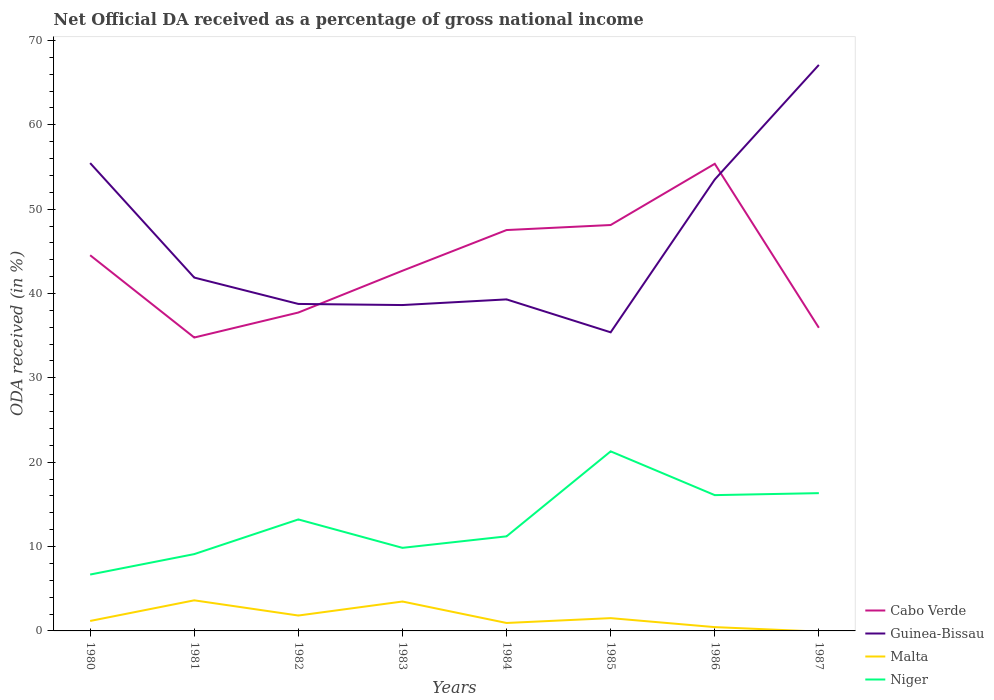Does the line corresponding to Malta intersect with the line corresponding to Guinea-Bissau?
Your answer should be compact. No. Across all years, what is the maximum net official DA received in Niger?
Offer a terse response. 6.68. What is the total net official DA received in Cabo Verde in the graph?
Provide a short and direct response. -10.84. What is the difference between the highest and the second highest net official DA received in Niger?
Provide a short and direct response. 14.6. What is the difference between the highest and the lowest net official DA received in Cabo Verde?
Ensure brevity in your answer.  4. Is the net official DA received in Guinea-Bissau strictly greater than the net official DA received in Malta over the years?
Ensure brevity in your answer.  No. How many lines are there?
Provide a short and direct response. 4. What is the difference between two consecutive major ticks on the Y-axis?
Your answer should be very brief. 10. Does the graph contain grids?
Provide a succinct answer. No. How many legend labels are there?
Your answer should be compact. 4. How are the legend labels stacked?
Ensure brevity in your answer.  Vertical. What is the title of the graph?
Ensure brevity in your answer.  Net Official DA received as a percentage of gross national income. Does "Haiti" appear as one of the legend labels in the graph?
Offer a terse response. No. What is the label or title of the Y-axis?
Make the answer very short. ODA received (in %). What is the ODA received (in %) in Cabo Verde in 1980?
Give a very brief answer. 44.54. What is the ODA received (in %) in Guinea-Bissau in 1980?
Your answer should be compact. 55.46. What is the ODA received (in %) in Malta in 1980?
Give a very brief answer. 1.18. What is the ODA received (in %) in Niger in 1980?
Keep it short and to the point. 6.68. What is the ODA received (in %) in Cabo Verde in 1981?
Offer a very short reply. 34.78. What is the ODA received (in %) in Guinea-Bissau in 1981?
Ensure brevity in your answer.  41.89. What is the ODA received (in %) in Malta in 1981?
Offer a terse response. 3.63. What is the ODA received (in %) in Niger in 1981?
Your answer should be compact. 9.11. What is the ODA received (in %) in Cabo Verde in 1982?
Give a very brief answer. 37.74. What is the ODA received (in %) in Guinea-Bissau in 1982?
Provide a succinct answer. 38.76. What is the ODA received (in %) of Malta in 1982?
Give a very brief answer. 1.83. What is the ODA received (in %) in Niger in 1982?
Offer a very short reply. 13.22. What is the ODA received (in %) of Cabo Verde in 1983?
Provide a succinct answer. 42.7. What is the ODA received (in %) in Guinea-Bissau in 1983?
Your answer should be very brief. 38.63. What is the ODA received (in %) in Malta in 1983?
Your response must be concise. 3.49. What is the ODA received (in %) of Niger in 1983?
Keep it short and to the point. 9.85. What is the ODA received (in %) of Cabo Verde in 1984?
Your answer should be compact. 47.52. What is the ODA received (in %) of Guinea-Bissau in 1984?
Provide a short and direct response. 39.3. What is the ODA received (in %) in Malta in 1984?
Your answer should be very brief. 0.94. What is the ODA received (in %) in Niger in 1984?
Ensure brevity in your answer.  11.21. What is the ODA received (in %) of Cabo Verde in 1985?
Your response must be concise. 48.12. What is the ODA received (in %) in Guinea-Bissau in 1985?
Ensure brevity in your answer.  35.4. What is the ODA received (in %) of Malta in 1985?
Ensure brevity in your answer.  1.52. What is the ODA received (in %) of Niger in 1985?
Your answer should be compact. 21.29. What is the ODA received (in %) of Cabo Verde in 1986?
Offer a terse response. 55.37. What is the ODA received (in %) in Guinea-Bissau in 1986?
Your response must be concise. 53.51. What is the ODA received (in %) in Malta in 1986?
Offer a very short reply. 0.45. What is the ODA received (in %) of Niger in 1986?
Make the answer very short. 16.1. What is the ODA received (in %) of Cabo Verde in 1987?
Offer a terse response. 35.94. What is the ODA received (in %) in Guinea-Bissau in 1987?
Provide a short and direct response. 67.1. What is the ODA received (in %) in Niger in 1987?
Your response must be concise. 16.33. Across all years, what is the maximum ODA received (in %) in Cabo Verde?
Provide a succinct answer. 55.37. Across all years, what is the maximum ODA received (in %) in Guinea-Bissau?
Your response must be concise. 67.1. Across all years, what is the maximum ODA received (in %) in Malta?
Offer a very short reply. 3.63. Across all years, what is the maximum ODA received (in %) of Niger?
Give a very brief answer. 21.29. Across all years, what is the minimum ODA received (in %) of Cabo Verde?
Your answer should be very brief. 34.78. Across all years, what is the minimum ODA received (in %) of Guinea-Bissau?
Provide a succinct answer. 35.4. Across all years, what is the minimum ODA received (in %) of Niger?
Make the answer very short. 6.68. What is the total ODA received (in %) of Cabo Verde in the graph?
Your response must be concise. 346.7. What is the total ODA received (in %) in Guinea-Bissau in the graph?
Your response must be concise. 370.05. What is the total ODA received (in %) in Malta in the graph?
Provide a succinct answer. 13.03. What is the total ODA received (in %) in Niger in the graph?
Offer a terse response. 103.78. What is the difference between the ODA received (in %) of Cabo Verde in 1980 and that in 1981?
Offer a very short reply. 9.75. What is the difference between the ODA received (in %) in Guinea-Bissau in 1980 and that in 1981?
Provide a succinct answer. 13.57. What is the difference between the ODA received (in %) in Malta in 1980 and that in 1981?
Make the answer very short. -2.44. What is the difference between the ODA received (in %) in Niger in 1980 and that in 1981?
Provide a succinct answer. -2.42. What is the difference between the ODA received (in %) in Cabo Verde in 1980 and that in 1982?
Your response must be concise. 6.79. What is the difference between the ODA received (in %) in Guinea-Bissau in 1980 and that in 1982?
Give a very brief answer. 16.7. What is the difference between the ODA received (in %) of Malta in 1980 and that in 1982?
Offer a terse response. -0.64. What is the difference between the ODA received (in %) of Niger in 1980 and that in 1982?
Ensure brevity in your answer.  -6.53. What is the difference between the ODA received (in %) of Cabo Verde in 1980 and that in 1983?
Your response must be concise. 1.84. What is the difference between the ODA received (in %) of Guinea-Bissau in 1980 and that in 1983?
Give a very brief answer. 16.83. What is the difference between the ODA received (in %) in Malta in 1980 and that in 1983?
Give a very brief answer. -2.3. What is the difference between the ODA received (in %) in Niger in 1980 and that in 1983?
Provide a short and direct response. -3.17. What is the difference between the ODA received (in %) in Cabo Verde in 1980 and that in 1984?
Your answer should be very brief. -2.99. What is the difference between the ODA received (in %) in Guinea-Bissau in 1980 and that in 1984?
Keep it short and to the point. 16.16. What is the difference between the ODA received (in %) of Malta in 1980 and that in 1984?
Your response must be concise. 0.24. What is the difference between the ODA received (in %) in Niger in 1980 and that in 1984?
Provide a succinct answer. -4.53. What is the difference between the ODA received (in %) of Cabo Verde in 1980 and that in 1985?
Give a very brief answer. -3.58. What is the difference between the ODA received (in %) of Guinea-Bissau in 1980 and that in 1985?
Provide a succinct answer. 20.06. What is the difference between the ODA received (in %) of Malta in 1980 and that in 1985?
Your answer should be compact. -0.33. What is the difference between the ODA received (in %) in Niger in 1980 and that in 1985?
Offer a terse response. -14.6. What is the difference between the ODA received (in %) of Cabo Verde in 1980 and that in 1986?
Your answer should be compact. -10.84. What is the difference between the ODA received (in %) of Guinea-Bissau in 1980 and that in 1986?
Provide a short and direct response. 1.95. What is the difference between the ODA received (in %) of Malta in 1980 and that in 1986?
Offer a very short reply. 0.73. What is the difference between the ODA received (in %) in Niger in 1980 and that in 1986?
Keep it short and to the point. -9.42. What is the difference between the ODA received (in %) of Cabo Verde in 1980 and that in 1987?
Make the answer very short. 8.6. What is the difference between the ODA received (in %) of Guinea-Bissau in 1980 and that in 1987?
Provide a succinct answer. -11.64. What is the difference between the ODA received (in %) of Niger in 1980 and that in 1987?
Keep it short and to the point. -9.65. What is the difference between the ODA received (in %) in Cabo Verde in 1981 and that in 1982?
Your answer should be very brief. -2.96. What is the difference between the ODA received (in %) of Guinea-Bissau in 1981 and that in 1982?
Offer a very short reply. 3.12. What is the difference between the ODA received (in %) of Malta in 1981 and that in 1982?
Give a very brief answer. 1.8. What is the difference between the ODA received (in %) in Niger in 1981 and that in 1982?
Your answer should be compact. -4.11. What is the difference between the ODA received (in %) of Cabo Verde in 1981 and that in 1983?
Your answer should be very brief. -7.92. What is the difference between the ODA received (in %) in Guinea-Bissau in 1981 and that in 1983?
Your answer should be compact. 3.26. What is the difference between the ODA received (in %) in Malta in 1981 and that in 1983?
Offer a terse response. 0.14. What is the difference between the ODA received (in %) in Niger in 1981 and that in 1983?
Keep it short and to the point. -0.74. What is the difference between the ODA received (in %) in Cabo Verde in 1981 and that in 1984?
Your answer should be very brief. -12.74. What is the difference between the ODA received (in %) of Guinea-Bissau in 1981 and that in 1984?
Your response must be concise. 2.59. What is the difference between the ODA received (in %) in Malta in 1981 and that in 1984?
Keep it short and to the point. 2.68. What is the difference between the ODA received (in %) in Niger in 1981 and that in 1984?
Provide a succinct answer. -2.11. What is the difference between the ODA received (in %) in Cabo Verde in 1981 and that in 1985?
Provide a short and direct response. -13.34. What is the difference between the ODA received (in %) of Guinea-Bissau in 1981 and that in 1985?
Your answer should be very brief. 6.49. What is the difference between the ODA received (in %) in Malta in 1981 and that in 1985?
Provide a short and direct response. 2.11. What is the difference between the ODA received (in %) in Niger in 1981 and that in 1985?
Your answer should be very brief. -12.18. What is the difference between the ODA received (in %) of Cabo Verde in 1981 and that in 1986?
Make the answer very short. -20.59. What is the difference between the ODA received (in %) of Guinea-Bissau in 1981 and that in 1986?
Your response must be concise. -11.63. What is the difference between the ODA received (in %) of Malta in 1981 and that in 1986?
Offer a terse response. 3.18. What is the difference between the ODA received (in %) in Niger in 1981 and that in 1986?
Make the answer very short. -6.99. What is the difference between the ODA received (in %) in Cabo Verde in 1981 and that in 1987?
Offer a terse response. -1.16. What is the difference between the ODA received (in %) in Guinea-Bissau in 1981 and that in 1987?
Your answer should be very brief. -25.21. What is the difference between the ODA received (in %) in Niger in 1981 and that in 1987?
Your response must be concise. -7.23. What is the difference between the ODA received (in %) in Cabo Verde in 1982 and that in 1983?
Provide a succinct answer. -4.95. What is the difference between the ODA received (in %) of Guinea-Bissau in 1982 and that in 1983?
Provide a succinct answer. 0.13. What is the difference between the ODA received (in %) in Malta in 1982 and that in 1983?
Your response must be concise. -1.66. What is the difference between the ODA received (in %) of Niger in 1982 and that in 1983?
Make the answer very short. 3.37. What is the difference between the ODA received (in %) of Cabo Verde in 1982 and that in 1984?
Your answer should be compact. -9.78. What is the difference between the ODA received (in %) of Guinea-Bissau in 1982 and that in 1984?
Provide a short and direct response. -0.54. What is the difference between the ODA received (in %) in Malta in 1982 and that in 1984?
Provide a succinct answer. 0.88. What is the difference between the ODA received (in %) in Niger in 1982 and that in 1984?
Make the answer very short. 2. What is the difference between the ODA received (in %) in Cabo Verde in 1982 and that in 1985?
Provide a short and direct response. -10.37. What is the difference between the ODA received (in %) of Guinea-Bissau in 1982 and that in 1985?
Provide a short and direct response. 3.36. What is the difference between the ODA received (in %) of Malta in 1982 and that in 1985?
Provide a short and direct response. 0.31. What is the difference between the ODA received (in %) of Niger in 1982 and that in 1985?
Your answer should be compact. -8.07. What is the difference between the ODA received (in %) in Cabo Verde in 1982 and that in 1986?
Offer a very short reply. -17.63. What is the difference between the ODA received (in %) in Guinea-Bissau in 1982 and that in 1986?
Ensure brevity in your answer.  -14.75. What is the difference between the ODA received (in %) of Malta in 1982 and that in 1986?
Provide a short and direct response. 1.37. What is the difference between the ODA received (in %) in Niger in 1982 and that in 1986?
Ensure brevity in your answer.  -2.88. What is the difference between the ODA received (in %) of Cabo Verde in 1982 and that in 1987?
Offer a very short reply. 1.81. What is the difference between the ODA received (in %) of Guinea-Bissau in 1982 and that in 1987?
Keep it short and to the point. -28.33. What is the difference between the ODA received (in %) in Niger in 1982 and that in 1987?
Ensure brevity in your answer.  -3.12. What is the difference between the ODA received (in %) of Cabo Verde in 1983 and that in 1984?
Make the answer very short. -4.82. What is the difference between the ODA received (in %) in Guinea-Bissau in 1983 and that in 1984?
Your response must be concise. -0.67. What is the difference between the ODA received (in %) of Malta in 1983 and that in 1984?
Give a very brief answer. 2.54. What is the difference between the ODA received (in %) of Niger in 1983 and that in 1984?
Offer a terse response. -1.36. What is the difference between the ODA received (in %) in Cabo Verde in 1983 and that in 1985?
Keep it short and to the point. -5.42. What is the difference between the ODA received (in %) in Guinea-Bissau in 1983 and that in 1985?
Keep it short and to the point. 3.23. What is the difference between the ODA received (in %) of Malta in 1983 and that in 1985?
Provide a succinct answer. 1.97. What is the difference between the ODA received (in %) in Niger in 1983 and that in 1985?
Your response must be concise. -11.44. What is the difference between the ODA received (in %) in Cabo Verde in 1983 and that in 1986?
Ensure brevity in your answer.  -12.68. What is the difference between the ODA received (in %) in Guinea-Bissau in 1983 and that in 1986?
Provide a succinct answer. -14.88. What is the difference between the ODA received (in %) of Malta in 1983 and that in 1986?
Ensure brevity in your answer.  3.03. What is the difference between the ODA received (in %) of Niger in 1983 and that in 1986?
Ensure brevity in your answer.  -6.25. What is the difference between the ODA received (in %) in Cabo Verde in 1983 and that in 1987?
Ensure brevity in your answer.  6.76. What is the difference between the ODA received (in %) of Guinea-Bissau in 1983 and that in 1987?
Your answer should be very brief. -28.47. What is the difference between the ODA received (in %) in Niger in 1983 and that in 1987?
Provide a succinct answer. -6.48. What is the difference between the ODA received (in %) of Cabo Verde in 1984 and that in 1985?
Ensure brevity in your answer.  -0.6. What is the difference between the ODA received (in %) in Guinea-Bissau in 1984 and that in 1985?
Make the answer very short. 3.9. What is the difference between the ODA received (in %) of Malta in 1984 and that in 1985?
Provide a short and direct response. -0.57. What is the difference between the ODA received (in %) in Niger in 1984 and that in 1985?
Your answer should be compact. -10.07. What is the difference between the ODA received (in %) in Cabo Verde in 1984 and that in 1986?
Give a very brief answer. -7.85. What is the difference between the ODA received (in %) of Guinea-Bissau in 1984 and that in 1986?
Provide a short and direct response. -14.21. What is the difference between the ODA received (in %) in Malta in 1984 and that in 1986?
Offer a very short reply. 0.49. What is the difference between the ODA received (in %) of Niger in 1984 and that in 1986?
Your response must be concise. -4.89. What is the difference between the ODA received (in %) in Cabo Verde in 1984 and that in 1987?
Your answer should be very brief. 11.59. What is the difference between the ODA received (in %) in Guinea-Bissau in 1984 and that in 1987?
Keep it short and to the point. -27.8. What is the difference between the ODA received (in %) of Niger in 1984 and that in 1987?
Give a very brief answer. -5.12. What is the difference between the ODA received (in %) of Cabo Verde in 1985 and that in 1986?
Your answer should be very brief. -7.26. What is the difference between the ODA received (in %) of Guinea-Bissau in 1985 and that in 1986?
Keep it short and to the point. -18.12. What is the difference between the ODA received (in %) of Malta in 1985 and that in 1986?
Offer a very short reply. 1.06. What is the difference between the ODA received (in %) in Niger in 1985 and that in 1986?
Give a very brief answer. 5.19. What is the difference between the ODA received (in %) of Cabo Verde in 1985 and that in 1987?
Provide a short and direct response. 12.18. What is the difference between the ODA received (in %) of Guinea-Bissau in 1985 and that in 1987?
Keep it short and to the point. -31.7. What is the difference between the ODA received (in %) in Niger in 1985 and that in 1987?
Provide a succinct answer. 4.95. What is the difference between the ODA received (in %) of Cabo Verde in 1986 and that in 1987?
Your response must be concise. 19.44. What is the difference between the ODA received (in %) of Guinea-Bissau in 1986 and that in 1987?
Offer a very short reply. -13.58. What is the difference between the ODA received (in %) of Niger in 1986 and that in 1987?
Keep it short and to the point. -0.23. What is the difference between the ODA received (in %) of Cabo Verde in 1980 and the ODA received (in %) of Guinea-Bissau in 1981?
Give a very brief answer. 2.65. What is the difference between the ODA received (in %) in Cabo Verde in 1980 and the ODA received (in %) in Malta in 1981?
Give a very brief answer. 40.91. What is the difference between the ODA received (in %) of Cabo Verde in 1980 and the ODA received (in %) of Niger in 1981?
Offer a terse response. 35.43. What is the difference between the ODA received (in %) in Guinea-Bissau in 1980 and the ODA received (in %) in Malta in 1981?
Your answer should be compact. 51.83. What is the difference between the ODA received (in %) of Guinea-Bissau in 1980 and the ODA received (in %) of Niger in 1981?
Provide a short and direct response. 46.35. What is the difference between the ODA received (in %) of Malta in 1980 and the ODA received (in %) of Niger in 1981?
Your response must be concise. -7.92. What is the difference between the ODA received (in %) in Cabo Verde in 1980 and the ODA received (in %) in Guinea-Bissau in 1982?
Your answer should be very brief. 5.77. What is the difference between the ODA received (in %) in Cabo Verde in 1980 and the ODA received (in %) in Malta in 1982?
Give a very brief answer. 42.71. What is the difference between the ODA received (in %) of Cabo Verde in 1980 and the ODA received (in %) of Niger in 1982?
Keep it short and to the point. 31.32. What is the difference between the ODA received (in %) of Guinea-Bissau in 1980 and the ODA received (in %) of Malta in 1982?
Offer a very short reply. 53.63. What is the difference between the ODA received (in %) in Guinea-Bissau in 1980 and the ODA received (in %) in Niger in 1982?
Provide a short and direct response. 42.24. What is the difference between the ODA received (in %) in Malta in 1980 and the ODA received (in %) in Niger in 1982?
Your response must be concise. -12.03. What is the difference between the ODA received (in %) in Cabo Verde in 1980 and the ODA received (in %) in Guinea-Bissau in 1983?
Ensure brevity in your answer.  5.9. What is the difference between the ODA received (in %) in Cabo Verde in 1980 and the ODA received (in %) in Malta in 1983?
Your answer should be very brief. 41.05. What is the difference between the ODA received (in %) of Cabo Verde in 1980 and the ODA received (in %) of Niger in 1983?
Your response must be concise. 34.69. What is the difference between the ODA received (in %) of Guinea-Bissau in 1980 and the ODA received (in %) of Malta in 1983?
Keep it short and to the point. 51.97. What is the difference between the ODA received (in %) in Guinea-Bissau in 1980 and the ODA received (in %) in Niger in 1983?
Provide a succinct answer. 45.61. What is the difference between the ODA received (in %) of Malta in 1980 and the ODA received (in %) of Niger in 1983?
Provide a succinct answer. -8.67. What is the difference between the ODA received (in %) of Cabo Verde in 1980 and the ODA received (in %) of Guinea-Bissau in 1984?
Provide a succinct answer. 5.23. What is the difference between the ODA received (in %) of Cabo Verde in 1980 and the ODA received (in %) of Malta in 1984?
Ensure brevity in your answer.  43.59. What is the difference between the ODA received (in %) in Cabo Verde in 1980 and the ODA received (in %) in Niger in 1984?
Offer a very short reply. 33.32. What is the difference between the ODA received (in %) in Guinea-Bissau in 1980 and the ODA received (in %) in Malta in 1984?
Give a very brief answer. 54.52. What is the difference between the ODA received (in %) in Guinea-Bissau in 1980 and the ODA received (in %) in Niger in 1984?
Your answer should be compact. 44.25. What is the difference between the ODA received (in %) in Malta in 1980 and the ODA received (in %) in Niger in 1984?
Provide a short and direct response. -10.03. What is the difference between the ODA received (in %) in Cabo Verde in 1980 and the ODA received (in %) in Guinea-Bissau in 1985?
Your response must be concise. 9.14. What is the difference between the ODA received (in %) in Cabo Verde in 1980 and the ODA received (in %) in Malta in 1985?
Ensure brevity in your answer.  43.02. What is the difference between the ODA received (in %) in Cabo Verde in 1980 and the ODA received (in %) in Niger in 1985?
Offer a very short reply. 23.25. What is the difference between the ODA received (in %) of Guinea-Bissau in 1980 and the ODA received (in %) of Malta in 1985?
Give a very brief answer. 53.94. What is the difference between the ODA received (in %) in Guinea-Bissau in 1980 and the ODA received (in %) in Niger in 1985?
Your answer should be very brief. 34.17. What is the difference between the ODA received (in %) in Malta in 1980 and the ODA received (in %) in Niger in 1985?
Keep it short and to the point. -20.1. What is the difference between the ODA received (in %) in Cabo Verde in 1980 and the ODA received (in %) in Guinea-Bissau in 1986?
Ensure brevity in your answer.  -8.98. What is the difference between the ODA received (in %) of Cabo Verde in 1980 and the ODA received (in %) of Malta in 1986?
Ensure brevity in your answer.  44.08. What is the difference between the ODA received (in %) in Cabo Verde in 1980 and the ODA received (in %) in Niger in 1986?
Your response must be concise. 28.44. What is the difference between the ODA received (in %) of Guinea-Bissau in 1980 and the ODA received (in %) of Malta in 1986?
Keep it short and to the point. 55.01. What is the difference between the ODA received (in %) in Guinea-Bissau in 1980 and the ODA received (in %) in Niger in 1986?
Your answer should be very brief. 39.36. What is the difference between the ODA received (in %) in Malta in 1980 and the ODA received (in %) in Niger in 1986?
Make the answer very short. -14.92. What is the difference between the ODA received (in %) in Cabo Verde in 1980 and the ODA received (in %) in Guinea-Bissau in 1987?
Your response must be concise. -22.56. What is the difference between the ODA received (in %) of Cabo Verde in 1980 and the ODA received (in %) of Niger in 1987?
Provide a succinct answer. 28.2. What is the difference between the ODA received (in %) of Guinea-Bissau in 1980 and the ODA received (in %) of Niger in 1987?
Your answer should be very brief. 39.13. What is the difference between the ODA received (in %) in Malta in 1980 and the ODA received (in %) in Niger in 1987?
Your answer should be compact. -15.15. What is the difference between the ODA received (in %) of Cabo Verde in 1981 and the ODA received (in %) of Guinea-Bissau in 1982?
Ensure brevity in your answer.  -3.98. What is the difference between the ODA received (in %) in Cabo Verde in 1981 and the ODA received (in %) in Malta in 1982?
Ensure brevity in your answer.  32.95. What is the difference between the ODA received (in %) in Cabo Verde in 1981 and the ODA received (in %) in Niger in 1982?
Your answer should be compact. 21.57. What is the difference between the ODA received (in %) of Guinea-Bissau in 1981 and the ODA received (in %) of Malta in 1982?
Your response must be concise. 40.06. What is the difference between the ODA received (in %) in Guinea-Bissau in 1981 and the ODA received (in %) in Niger in 1982?
Offer a terse response. 28.67. What is the difference between the ODA received (in %) of Malta in 1981 and the ODA received (in %) of Niger in 1982?
Your answer should be very brief. -9.59. What is the difference between the ODA received (in %) of Cabo Verde in 1981 and the ODA received (in %) of Guinea-Bissau in 1983?
Provide a succinct answer. -3.85. What is the difference between the ODA received (in %) of Cabo Verde in 1981 and the ODA received (in %) of Malta in 1983?
Provide a succinct answer. 31.29. What is the difference between the ODA received (in %) of Cabo Verde in 1981 and the ODA received (in %) of Niger in 1983?
Your answer should be very brief. 24.93. What is the difference between the ODA received (in %) of Guinea-Bissau in 1981 and the ODA received (in %) of Malta in 1983?
Provide a succinct answer. 38.4. What is the difference between the ODA received (in %) of Guinea-Bissau in 1981 and the ODA received (in %) of Niger in 1983?
Ensure brevity in your answer.  32.04. What is the difference between the ODA received (in %) in Malta in 1981 and the ODA received (in %) in Niger in 1983?
Make the answer very short. -6.22. What is the difference between the ODA received (in %) of Cabo Verde in 1981 and the ODA received (in %) of Guinea-Bissau in 1984?
Your answer should be very brief. -4.52. What is the difference between the ODA received (in %) in Cabo Verde in 1981 and the ODA received (in %) in Malta in 1984?
Your answer should be compact. 33.84. What is the difference between the ODA received (in %) in Cabo Verde in 1981 and the ODA received (in %) in Niger in 1984?
Offer a terse response. 23.57. What is the difference between the ODA received (in %) of Guinea-Bissau in 1981 and the ODA received (in %) of Malta in 1984?
Your answer should be very brief. 40.94. What is the difference between the ODA received (in %) of Guinea-Bissau in 1981 and the ODA received (in %) of Niger in 1984?
Your response must be concise. 30.67. What is the difference between the ODA received (in %) in Malta in 1981 and the ODA received (in %) in Niger in 1984?
Keep it short and to the point. -7.59. What is the difference between the ODA received (in %) in Cabo Verde in 1981 and the ODA received (in %) in Guinea-Bissau in 1985?
Make the answer very short. -0.62. What is the difference between the ODA received (in %) in Cabo Verde in 1981 and the ODA received (in %) in Malta in 1985?
Provide a short and direct response. 33.26. What is the difference between the ODA received (in %) in Cabo Verde in 1981 and the ODA received (in %) in Niger in 1985?
Your response must be concise. 13.49. What is the difference between the ODA received (in %) of Guinea-Bissau in 1981 and the ODA received (in %) of Malta in 1985?
Offer a terse response. 40.37. What is the difference between the ODA received (in %) in Guinea-Bissau in 1981 and the ODA received (in %) in Niger in 1985?
Provide a short and direct response. 20.6. What is the difference between the ODA received (in %) in Malta in 1981 and the ODA received (in %) in Niger in 1985?
Keep it short and to the point. -17.66. What is the difference between the ODA received (in %) in Cabo Verde in 1981 and the ODA received (in %) in Guinea-Bissau in 1986?
Your response must be concise. -18.73. What is the difference between the ODA received (in %) in Cabo Verde in 1981 and the ODA received (in %) in Malta in 1986?
Offer a very short reply. 34.33. What is the difference between the ODA received (in %) in Cabo Verde in 1981 and the ODA received (in %) in Niger in 1986?
Keep it short and to the point. 18.68. What is the difference between the ODA received (in %) of Guinea-Bissau in 1981 and the ODA received (in %) of Malta in 1986?
Make the answer very short. 41.44. What is the difference between the ODA received (in %) of Guinea-Bissau in 1981 and the ODA received (in %) of Niger in 1986?
Give a very brief answer. 25.79. What is the difference between the ODA received (in %) in Malta in 1981 and the ODA received (in %) in Niger in 1986?
Your answer should be very brief. -12.47. What is the difference between the ODA received (in %) in Cabo Verde in 1981 and the ODA received (in %) in Guinea-Bissau in 1987?
Offer a very short reply. -32.32. What is the difference between the ODA received (in %) of Cabo Verde in 1981 and the ODA received (in %) of Niger in 1987?
Your answer should be very brief. 18.45. What is the difference between the ODA received (in %) of Guinea-Bissau in 1981 and the ODA received (in %) of Niger in 1987?
Provide a short and direct response. 25.55. What is the difference between the ODA received (in %) in Malta in 1981 and the ODA received (in %) in Niger in 1987?
Provide a succinct answer. -12.71. What is the difference between the ODA received (in %) of Cabo Verde in 1982 and the ODA received (in %) of Guinea-Bissau in 1983?
Offer a terse response. -0.89. What is the difference between the ODA received (in %) in Cabo Verde in 1982 and the ODA received (in %) in Malta in 1983?
Provide a succinct answer. 34.26. What is the difference between the ODA received (in %) in Cabo Verde in 1982 and the ODA received (in %) in Niger in 1983?
Your answer should be compact. 27.89. What is the difference between the ODA received (in %) of Guinea-Bissau in 1982 and the ODA received (in %) of Malta in 1983?
Make the answer very short. 35.28. What is the difference between the ODA received (in %) of Guinea-Bissau in 1982 and the ODA received (in %) of Niger in 1983?
Offer a terse response. 28.91. What is the difference between the ODA received (in %) of Malta in 1982 and the ODA received (in %) of Niger in 1983?
Make the answer very short. -8.02. What is the difference between the ODA received (in %) in Cabo Verde in 1982 and the ODA received (in %) in Guinea-Bissau in 1984?
Give a very brief answer. -1.56. What is the difference between the ODA received (in %) of Cabo Verde in 1982 and the ODA received (in %) of Malta in 1984?
Your answer should be very brief. 36.8. What is the difference between the ODA received (in %) in Cabo Verde in 1982 and the ODA received (in %) in Niger in 1984?
Provide a short and direct response. 26.53. What is the difference between the ODA received (in %) in Guinea-Bissau in 1982 and the ODA received (in %) in Malta in 1984?
Your response must be concise. 37.82. What is the difference between the ODA received (in %) in Guinea-Bissau in 1982 and the ODA received (in %) in Niger in 1984?
Keep it short and to the point. 27.55. What is the difference between the ODA received (in %) in Malta in 1982 and the ODA received (in %) in Niger in 1984?
Keep it short and to the point. -9.39. What is the difference between the ODA received (in %) of Cabo Verde in 1982 and the ODA received (in %) of Guinea-Bissau in 1985?
Make the answer very short. 2.35. What is the difference between the ODA received (in %) in Cabo Verde in 1982 and the ODA received (in %) in Malta in 1985?
Make the answer very short. 36.23. What is the difference between the ODA received (in %) in Cabo Verde in 1982 and the ODA received (in %) in Niger in 1985?
Give a very brief answer. 16.46. What is the difference between the ODA received (in %) of Guinea-Bissau in 1982 and the ODA received (in %) of Malta in 1985?
Offer a very short reply. 37.25. What is the difference between the ODA received (in %) in Guinea-Bissau in 1982 and the ODA received (in %) in Niger in 1985?
Give a very brief answer. 17.48. What is the difference between the ODA received (in %) in Malta in 1982 and the ODA received (in %) in Niger in 1985?
Provide a succinct answer. -19.46. What is the difference between the ODA received (in %) in Cabo Verde in 1982 and the ODA received (in %) in Guinea-Bissau in 1986?
Your answer should be compact. -15.77. What is the difference between the ODA received (in %) of Cabo Verde in 1982 and the ODA received (in %) of Malta in 1986?
Make the answer very short. 37.29. What is the difference between the ODA received (in %) of Cabo Verde in 1982 and the ODA received (in %) of Niger in 1986?
Your answer should be very brief. 21.64. What is the difference between the ODA received (in %) in Guinea-Bissau in 1982 and the ODA received (in %) in Malta in 1986?
Offer a very short reply. 38.31. What is the difference between the ODA received (in %) of Guinea-Bissau in 1982 and the ODA received (in %) of Niger in 1986?
Keep it short and to the point. 22.66. What is the difference between the ODA received (in %) in Malta in 1982 and the ODA received (in %) in Niger in 1986?
Your response must be concise. -14.27. What is the difference between the ODA received (in %) in Cabo Verde in 1982 and the ODA received (in %) in Guinea-Bissau in 1987?
Provide a succinct answer. -29.35. What is the difference between the ODA received (in %) of Cabo Verde in 1982 and the ODA received (in %) of Niger in 1987?
Ensure brevity in your answer.  21.41. What is the difference between the ODA received (in %) in Guinea-Bissau in 1982 and the ODA received (in %) in Niger in 1987?
Ensure brevity in your answer.  22.43. What is the difference between the ODA received (in %) of Malta in 1982 and the ODA received (in %) of Niger in 1987?
Your answer should be very brief. -14.51. What is the difference between the ODA received (in %) in Cabo Verde in 1983 and the ODA received (in %) in Guinea-Bissau in 1984?
Provide a short and direct response. 3.4. What is the difference between the ODA received (in %) of Cabo Verde in 1983 and the ODA received (in %) of Malta in 1984?
Ensure brevity in your answer.  41.75. What is the difference between the ODA received (in %) in Cabo Verde in 1983 and the ODA received (in %) in Niger in 1984?
Provide a short and direct response. 31.48. What is the difference between the ODA received (in %) in Guinea-Bissau in 1983 and the ODA received (in %) in Malta in 1984?
Offer a very short reply. 37.69. What is the difference between the ODA received (in %) in Guinea-Bissau in 1983 and the ODA received (in %) in Niger in 1984?
Make the answer very short. 27.42. What is the difference between the ODA received (in %) of Malta in 1983 and the ODA received (in %) of Niger in 1984?
Ensure brevity in your answer.  -7.73. What is the difference between the ODA received (in %) of Cabo Verde in 1983 and the ODA received (in %) of Guinea-Bissau in 1985?
Keep it short and to the point. 7.3. What is the difference between the ODA received (in %) in Cabo Verde in 1983 and the ODA received (in %) in Malta in 1985?
Your answer should be compact. 41.18. What is the difference between the ODA received (in %) in Cabo Verde in 1983 and the ODA received (in %) in Niger in 1985?
Offer a terse response. 21.41. What is the difference between the ODA received (in %) in Guinea-Bissau in 1983 and the ODA received (in %) in Malta in 1985?
Provide a succinct answer. 37.11. What is the difference between the ODA received (in %) of Guinea-Bissau in 1983 and the ODA received (in %) of Niger in 1985?
Provide a short and direct response. 17.34. What is the difference between the ODA received (in %) in Malta in 1983 and the ODA received (in %) in Niger in 1985?
Your response must be concise. -17.8. What is the difference between the ODA received (in %) in Cabo Verde in 1983 and the ODA received (in %) in Guinea-Bissau in 1986?
Your answer should be compact. -10.82. What is the difference between the ODA received (in %) of Cabo Verde in 1983 and the ODA received (in %) of Malta in 1986?
Ensure brevity in your answer.  42.25. What is the difference between the ODA received (in %) of Cabo Verde in 1983 and the ODA received (in %) of Niger in 1986?
Keep it short and to the point. 26.6. What is the difference between the ODA received (in %) in Guinea-Bissau in 1983 and the ODA received (in %) in Malta in 1986?
Your answer should be very brief. 38.18. What is the difference between the ODA received (in %) of Guinea-Bissau in 1983 and the ODA received (in %) of Niger in 1986?
Make the answer very short. 22.53. What is the difference between the ODA received (in %) in Malta in 1983 and the ODA received (in %) in Niger in 1986?
Make the answer very short. -12.61. What is the difference between the ODA received (in %) in Cabo Verde in 1983 and the ODA received (in %) in Guinea-Bissau in 1987?
Offer a terse response. -24.4. What is the difference between the ODA received (in %) of Cabo Verde in 1983 and the ODA received (in %) of Niger in 1987?
Offer a very short reply. 26.36. What is the difference between the ODA received (in %) in Guinea-Bissau in 1983 and the ODA received (in %) in Niger in 1987?
Ensure brevity in your answer.  22.3. What is the difference between the ODA received (in %) of Malta in 1983 and the ODA received (in %) of Niger in 1987?
Your answer should be very brief. -12.85. What is the difference between the ODA received (in %) in Cabo Verde in 1984 and the ODA received (in %) in Guinea-Bissau in 1985?
Give a very brief answer. 12.12. What is the difference between the ODA received (in %) in Cabo Verde in 1984 and the ODA received (in %) in Malta in 1985?
Keep it short and to the point. 46. What is the difference between the ODA received (in %) of Cabo Verde in 1984 and the ODA received (in %) of Niger in 1985?
Ensure brevity in your answer.  26.23. What is the difference between the ODA received (in %) of Guinea-Bissau in 1984 and the ODA received (in %) of Malta in 1985?
Give a very brief answer. 37.78. What is the difference between the ODA received (in %) of Guinea-Bissau in 1984 and the ODA received (in %) of Niger in 1985?
Your answer should be compact. 18.01. What is the difference between the ODA received (in %) of Malta in 1984 and the ODA received (in %) of Niger in 1985?
Keep it short and to the point. -20.34. What is the difference between the ODA received (in %) of Cabo Verde in 1984 and the ODA received (in %) of Guinea-Bissau in 1986?
Provide a succinct answer. -5.99. What is the difference between the ODA received (in %) of Cabo Verde in 1984 and the ODA received (in %) of Malta in 1986?
Ensure brevity in your answer.  47.07. What is the difference between the ODA received (in %) in Cabo Verde in 1984 and the ODA received (in %) in Niger in 1986?
Make the answer very short. 31.42. What is the difference between the ODA received (in %) in Guinea-Bissau in 1984 and the ODA received (in %) in Malta in 1986?
Provide a succinct answer. 38.85. What is the difference between the ODA received (in %) in Guinea-Bissau in 1984 and the ODA received (in %) in Niger in 1986?
Your answer should be compact. 23.2. What is the difference between the ODA received (in %) of Malta in 1984 and the ODA received (in %) of Niger in 1986?
Give a very brief answer. -15.16. What is the difference between the ODA received (in %) in Cabo Verde in 1984 and the ODA received (in %) in Guinea-Bissau in 1987?
Ensure brevity in your answer.  -19.58. What is the difference between the ODA received (in %) of Cabo Verde in 1984 and the ODA received (in %) of Niger in 1987?
Your answer should be compact. 31.19. What is the difference between the ODA received (in %) of Guinea-Bissau in 1984 and the ODA received (in %) of Niger in 1987?
Offer a terse response. 22.97. What is the difference between the ODA received (in %) in Malta in 1984 and the ODA received (in %) in Niger in 1987?
Your answer should be very brief. -15.39. What is the difference between the ODA received (in %) in Cabo Verde in 1985 and the ODA received (in %) in Guinea-Bissau in 1986?
Offer a terse response. -5.4. What is the difference between the ODA received (in %) of Cabo Verde in 1985 and the ODA received (in %) of Malta in 1986?
Keep it short and to the point. 47.67. What is the difference between the ODA received (in %) of Cabo Verde in 1985 and the ODA received (in %) of Niger in 1986?
Your answer should be very brief. 32.02. What is the difference between the ODA received (in %) in Guinea-Bissau in 1985 and the ODA received (in %) in Malta in 1986?
Make the answer very short. 34.95. What is the difference between the ODA received (in %) in Guinea-Bissau in 1985 and the ODA received (in %) in Niger in 1986?
Provide a succinct answer. 19.3. What is the difference between the ODA received (in %) in Malta in 1985 and the ODA received (in %) in Niger in 1986?
Provide a succinct answer. -14.58. What is the difference between the ODA received (in %) in Cabo Verde in 1985 and the ODA received (in %) in Guinea-Bissau in 1987?
Your response must be concise. -18.98. What is the difference between the ODA received (in %) of Cabo Verde in 1985 and the ODA received (in %) of Niger in 1987?
Offer a terse response. 31.79. What is the difference between the ODA received (in %) in Guinea-Bissau in 1985 and the ODA received (in %) in Niger in 1987?
Provide a short and direct response. 19.07. What is the difference between the ODA received (in %) in Malta in 1985 and the ODA received (in %) in Niger in 1987?
Your response must be concise. -14.82. What is the difference between the ODA received (in %) of Cabo Verde in 1986 and the ODA received (in %) of Guinea-Bissau in 1987?
Give a very brief answer. -11.72. What is the difference between the ODA received (in %) in Cabo Verde in 1986 and the ODA received (in %) in Niger in 1987?
Your answer should be very brief. 39.04. What is the difference between the ODA received (in %) of Guinea-Bissau in 1986 and the ODA received (in %) of Niger in 1987?
Your answer should be compact. 37.18. What is the difference between the ODA received (in %) in Malta in 1986 and the ODA received (in %) in Niger in 1987?
Your response must be concise. -15.88. What is the average ODA received (in %) in Cabo Verde per year?
Provide a short and direct response. 43.34. What is the average ODA received (in %) of Guinea-Bissau per year?
Provide a short and direct response. 46.26. What is the average ODA received (in %) of Malta per year?
Give a very brief answer. 1.63. What is the average ODA received (in %) of Niger per year?
Offer a terse response. 12.97. In the year 1980, what is the difference between the ODA received (in %) of Cabo Verde and ODA received (in %) of Guinea-Bissau?
Keep it short and to the point. -10.93. In the year 1980, what is the difference between the ODA received (in %) of Cabo Verde and ODA received (in %) of Malta?
Give a very brief answer. 43.35. In the year 1980, what is the difference between the ODA received (in %) in Cabo Verde and ODA received (in %) in Niger?
Provide a short and direct response. 37.85. In the year 1980, what is the difference between the ODA received (in %) in Guinea-Bissau and ODA received (in %) in Malta?
Ensure brevity in your answer.  54.28. In the year 1980, what is the difference between the ODA received (in %) in Guinea-Bissau and ODA received (in %) in Niger?
Offer a very short reply. 48.78. In the year 1980, what is the difference between the ODA received (in %) in Malta and ODA received (in %) in Niger?
Give a very brief answer. -5.5. In the year 1981, what is the difference between the ODA received (in %) of Cabo Verde and ODA received (in %) of Guinea-Bissau?
Your response must be concise. -7.11. In the year 1981, what is the difference between the ODA received (in %) of Cabo Verde and ODA received (in %) of Malta?
Ensure brevity in your answer.  31.15. In the year 1981, what is the difference between the ODA received (in %) of Cabo Verde and ODA received (in %) of Niger?
Keep it short and to the point. 25.67. In the year 1981, what is the difference between the ODA received (in %) in Guinea-Bissau and ODA received (in %) in Malta?
Provide a succinct answer. 38.26. In the year 1981, what is the difference between the ODA received (in %) in Guinea-Bissau and ODA received (in %) in Niger?
Offer a terse response. 32.78. In the year 1981, what is the difference between the ODA received (in %) of Malta and ODA received (in %) of Niger?
Your answer should be very brief. -5.48. In the year 1982, what is the difference between the ODA received (in %) of Cabo Verde and ODA received (in %) of Guinea-Bissau?
Your answer should be very brief. -1.02. In the year 1982, what is the difference between the ODA received (in %) in Cabo Verde and ODA received (in %) in Malta?
Make the answer very short. 35.92. In the year 1982, what is the difference between the ODA received (in %) in Cabo Verde and ODA received (in %) in Niger?
Your response must be concise. 24.53. In the year 1982, what is the difference between the ODA received (in %) in Guinea-Bissau and ODA received (in %) in Malta?
Provide a succinct answer. 36.94. In the year 1982, what is the difference between the ODA received (in %) in Guinea-Bissau and ODA received (in %) in Niger?
Offer a very short reply. 25.55. In the year 1982, what is the difference between the ODA received (in %) in Malta and ODA received (in %) in Niger?
Your answer should be very brief. -11.39. In the year 1983, what is the difference between the ODA received (in %) of Cabo Verde and ODA received (in %) of Guinea-Bissau?
Your answer should be very brief. 4.07. In the year 1983, what is the difference between the ODA received (in %) of Cabo Verde and ODA received (in %) of Malta?
Give a very brief answer. 39.21. In the year 1983, what is the difference between the ODA received (in %) of Cabo Verde and ODA received (in %) of Niger?
Provide a succinct answer. 32.85. In the year 1983, what is the difference between the ODA received (in %) in Guinea-Bissau and ODA received (in %) in Malta?
Keep it short and to the point. 35.14. In the year 1983, what is the difference between the ODA received (in %) of Guinea-Bissau and ODA received (in %) of Niger?
Provide a succinct answer. 28.78. In the year 1983, what is the difference between the ODA received (in %) in Malta and ODA received (in %) in Niger?
Keep it short and to the point. -6.36. In the year 1984, what is the difference between the ODA received (in %) of Cabo Verde and ODA received (in %) of Guinea-Bissau?
Give a very brief answer. 8.22. In the year 1984, what is the difference between the ODA received (in %) of Cabo Verde and ODA received (in %) of Malta?
Your response must be concise. 46.58. In the year 1984, what is the difference between the ODA received (in %) of Cabo Verde and ODA received (in %) of Niger?
Offer a terse response. 36.31. In the year 1984, what is the difference between the ODA received (in %) in Guinea-Bissau and ODA received (in %) in Malta?
Offer a very short reply. 38.36. In the year 1984, what is the difference between the ODA received (in %) of Guinea-Bissau and ODA received (in %) of Niger?
Give a very brief answer. 28.09. In the year 1984, what is the difference between the ODA received (in %) in Malta and ODA received (in %) in Niger?
Your answer should be compact. -10.27. In the year 1985, what is the difference between the ODA received (in %) of Cabo Verde and ODA received (in %) of Guinea-Bissau?
Make the answer very short. 12.72. In the year 1985, what is the difference between the ODA received (in %) in Cabo Verde and ODA received (in %) in Malta?
Offer a very short reply. 46.6. In the year 1985, what is the difference between the ODA received (in %) of Cabo Verde and ODA received (in %) of Niger?
Provide a short and direct response. 26.83. In the year 1985, what is the difference between the ODA received (in %) in Guinea-Bissau and ODA received (in %) in Malta?
Provide a succinct answer. 33.88. In the year 1985, what is the difference between the ODA received (in %) in Guinea-Bissau and ODA received (in %) in Niger?
Your response must be concise. 14.11. In the year 1985, what is the difference between the ODA received (in %) of Malta and ODA received (in %) of Niger?
Provide a succinct answer. -19.77. In the year 1986, what is the difference between the ODA received (in %) of Cabo Verde and ODA received (in %) of Guinea-Bissau?
Give a very brief answer. 1.86. In the year 1986, what is the difference between the ODA received (in %) of Cabo Verde and ODA received (in %) of Malta?
Provide a short and direct response. 54.92. In the year 1986, what is the difference between the ODA received (in %) in Cabo Verde and ODA received (in %) in Niger?
Your answer should be very brief. 39.28. In the year 1986, what is the difference between the ODA received (in %) in Guinea-Bissau and ODA received (in %) in Malta?
Your answer should be very brief. 53.06. In the year 1986, what is the difference between the ODA received (in %) of Guinea-Bissau and ODA received (in %) of Niger?
Your answer should be compact. 37.41. In the year 1986, what is the difference between the ODA received (in %) of Malta and ODA received (in %) of Niger?
Keep it short and to the point. -15.65. In the year 1987, what is the difference between the ODA received (in %) of Cabo Verde and ODA received (in %) of Guinea-Bissau?
Offer a very short reply. -31.16. In the year 1987, what is the difference between the ODA received (in %) in Cabo Verde and ODA received (in %) in Niger?
Offer a very short reply. 19.6. In the year 1987, what is the difference between the ODA received (in %) in Guinea-Bissau and ODA received (in %) in Niger?
Keep it short and to the point. 50.76. What is the ratio of the ODA received (in %) in Cabo Verde in 1980 to that in 1981?
Your response must be concise. 1.28. What is the ratio of the ODA received (in %) in Guinea-Bissau in 1980 to that in 1981?
Give a very brief answer. 1.32. What is the ratio of the ODA received (in %) of Malta in 1980 to that in 1981?
Keep it short and to the point. 0.33. What is the ratio of the ODA received (in %) of Niger in 1980 to that in 1981?
Your answer should be compact. 0.73. What is the ratio of the ODA received (in %) of Cabo Verde in 1980 to that in 1982?
Your answer should be compact. 1.18. What is the ratio of the ODA received (in %) in Guinea-Bissau in 1980 to that in 1982?
Offer a very short reply. 1.43. What is the ratio of the ODA received (in %) of Malta in 1980 to that in 1982?
Provide a short and direct response. 0.65. What is the ratio of the ODA received (in %) of Niger in 1980 to that in 1982?
Keep it short and to the point. 0.51. What is the ratio of the ODA received (in %) in Cabo Verde in 1980 to that in 1983?
Give a very brief answer. 1.04. What is the ratio of the ODA received (in %) of Guinea-Bissau in 1980 to that in 1983?
Keep it short and to the point. 1.44. What is the ratio of the ODA received (in %) in Malta in 1980 to that in 1983?
Give a very brief answer. 0.34. What is the ratio of the ODA received (in %) of Niger in 1980 to that in 1983?
Offer a very short reply. 0.68. What is the ratio of the ODA received (in %) of Cabo Verde in 1980 to that in 1984?
Provide a short and direct response. 0.94. What is the ratio of the ODA received (in %) in Guinea-Bissau in 1980 to that in 1984?
Your answer should be very brief. 1.41. What is the ratio of the ODA received (in %) in Malta in 1980 to that in 1984?
Offer a terse response. 1.25. What is the ratio of the ODA received (in %) of Niger in 1980 to that in 1984?
Give a very brief answer. 0.6. What is the ratio of the ODA received (in %) in Cabo Verde in 1980 to that in 1985?
Make the answer very short. 0.93. What is the ratio of the ODA received (in %) in Guinea-Bissau in 1980 to that in 1985?
Offer a terse response. 1.57. What is the ratio of the ODA received (in %) in Malta in 1980 to that in 1985?
Provide a succinct answer. 0.78. What is the ratio of the ODA received (in %) in Niger in 1980 to that in 1985?
Make the answer very short. 0.31. What is the ratio of the ODA received (in %) of Cabo Verde in 1980 to that in 1986?
Keep it short and to the point. 0.8. What is the ratio of the ODA received (in %) in Guinea-Bissau in 1980 to that in 1986?
Offer a terse response. 1.04. What is the ratio of the ODA received (in %) of Malta in 1980 to that in 1986?
Your response must be concise. 2.62. What is the ratio of the ODA received (in %) in Niger in 1980 to that in 1986?
Keep it short and to the point. 0.42. What is the ratio of the ODA received (in %) of Cabo Verde in 1980 to that in 1987?
Offer a very short reply. 1.24. What is the ratio of the ODA received (in %) in Guinea-Bissau in 1980 to that in 1987?
Keep it short and to the point. 0.83. What is the ratio of the ODA received (in %) of Niger in 1980 to that in 1987?
Ensure brevity in your answer.  0.41. What is the ratio of the ODA received (in %) of Cabo Verde in 1981 to that in 1982?
Offer a terse response. 0.92. What is the ratio of the ODA received (in %) in Guinea-Bissau in 1981 to that in 1982?
Offer a terse response. 1.08. What is the ratio of the ODA received (in %) of Malta in 1981 to that in 1982?
Offer a terse response. 1.99. What is the ratio of the ODA received (in %) of Niger in 1981 to that in 1982?
Provide a succinct answer. 0.69. What is the ratio of the ODA received (in %) of Cabo Verde in 1981 to that in 1983?
Provide a succinct answer. 0.81. What is the ratio of the ODA received (in %) of Guinea-Bissau in 1981 to that in 1983?
Give a very brief answer. 1.08. What is the ratio of the ODA received (in %) of Malta in 1981 to that in 1983?
Ensure brevity in your answer.  1.04. What is the ratio of the ODA received (in %) in Niger in 1981 to that in 1983?
Make the answer very short. 0.92. What is the ratio of the ODA received (in %) in Cabo Verde in 1981 to that in 1984?
Make the answer very short. 0.73. What is the ratio of the ODA received (in %) in Guinea-Bissau in 1981 to that in 1984?
Provide a succinct answer. 1.07. What is the ratio of the ODA received (in %) of Malta in 1981 to that in 1984?
Provide a short and direct response. 3.85. What is the ratio of the ODA received (in %) of Niger in 1981 to that in 1984?
Ensure brevity in your answer.  0.81. What is the ratio of the ODA received (in %) of Cabo Verde in 1981 to that in 1985?
Your answer should be compact. 0.72. What is the ratio of the ODA received (in %) in Guinea-Bissau in 1981 to that in 1985?
Give a very brief answer. 1.18. What is the ratio of the ODA received (in %) of Malta in 1981 to that in 1985?
Keep it short and to the point. 2.39. What is the ratio of the ODA received (in %) in Niger in 1981 to that in 1985?
Your answer should be very brief. 0.43. What is the ratio of the ODA received (in %) of Cabo Verde in 1981 to that in 1986?
Offer a terse response. 0.63. What is the ratio of the ODA received (in %) in Guinea-Bissau in 1981 to that in 1986?
Offer a terse response. 0.78. What is the ratio of the ODA received (in %) in Malta in 1981 to that in 1986?
Make the answer very short. 8.04. What is the ratio of the ODA received (in %) in Niger in 1981 to that in 1986?
Provide a short and direct response. 0.57. What is the ratio of the ODA received (in %) in Cabo Verde in 1981 to that in 1987?
Make the answer very short. 0.97. What is the ratio of the ODA received (in %) of Guinea-Bissau in 1981 to that in 1987?
Provide a short and direct response. 0.62. What is the ratio of the ODA received (in %) in Niger in 1981 to that in 1987?
Provide a succinct answer. 0.56. What is the ratio of the ODA received (in %) in Cabo Verde in 1982 to that in 1983?
Ensure brevity in your answer.  0.88. What is the ratio of the ODA received (in %) of Malta in 1982 to that in 1983?
Your answer should be compact. 0.52. What is the ratio of the ODA received (in %) of Niger in 1982 to that in 1983?
Your response must be concise. 1.34. What is the ratio of the ODA received (in %) of Cabo Verde in 1982 to that in 1984?
Make the answer very short. 0.79. What is the ratio of the ODA received (in %) of Guinea-Bissau in 1982 to that in 1984?
Give a very brief answer. 0.99. What is the ratio of the ODA received (in %) in Malta in 1982 to that in 1984?
Provide a short and direct response. 1.94. What is the ratio of the ODA received (in %) in Niger in 1982 to that in 1984?
Ensure brevity in your answer.  1.18. What is the ratio of the ODA received (in %) of Cabo Verde in 1982 to that in 1985?
Provide a short and direct response. 0.78. What is the ratio of the ODA received (in %) in Guinea-Bissau in 1982 to that in 1985?
Offer a very short reply. 1.1. What is the ratio of the ODA received (in %) of Malta in 1982 to that in 1985?
Your answer should be compact. 1.2. What is the ratio of the ODA received (in %) of Niger in 1982 to that in 1985?
Ensure brevity in your answer.  0.62. What is the ratio of the ODA received (in %) of Cabo Verde in 1982 to that in 1986?
Offer a very short reply. 0.68. What is the ratio of the ODA received (in %) of Guinea-Bissau in 1982 to that in 1986?
Offer a very short reply. 0.72. What is the ratio of the ODA received (in %) of Malta in 1982 to that in 1986?
Provide a short and direct response. 4.05. What is the ratio of the ODA received (in %) of Niger in 1982 to that in 1986?
Give a very brief answer. 0.82. What is the ratio of the ODA received (in %) in Cabo Verde in 1982 to that in 1987?
Your answer should be very brief. 1.05. What is the ratio of the ODA received (in %) of Guinea-Bissau in 1982 to that in 1987?
Provide a short and direct response. 0.58. What is the ratio of the ODA received (in %) of Niger in 1982 to that in 1987?
Provide a short and direct response. 0.81. What is the ratio of the ODA received (in %) of Cabo Verde in 1983 to that in 1984?
Give a very brief answer. 0.9. What is the ratio of the ODA received (in %) of Malta in 1983 to that in 1984?
Your answer should be compact. 3.7. What is the ratio of the ODA received (in %) of Niger in 1983 to that in 1984?
Offer a terse response. 0.88. What is the ratio of the ODA received (in %) of Cabo Verde in 1983 to that in 1985?
Make the answer very short. 0.89. What is the ratio of the ODA received (in %) of Guinea-Bissau in 1983 to that in 1985?
Your response must be concise. 1.09. What is the ratio of the ODA received (in %) in Malta in 1983 to that in 1985?
Provide a succinct answer. 2.3. What is the ratio of the ODA received (in %) in Niger in 1983 to that in 1985?
Offer a very short reply. 0.46. What is the ratio of the ODA received (in %) in Cabo Verde in 1983 to that in 1986?
Make the answer very short. 0.77. What is the ratio of the ODA received (in %) in Guinea-Bissau in 1983 to that in 1986?
Provide a short and direct response. 0.72. What is the ratio of the ODA received (in %) in Malta in 1983 to that in 1986?
Offer a very short reply. 7.73. What is the ratio of the ODA received (in %) of Niger in 1983 to that in 1986?
Ensure brevity in your answer.  0.61. What is the ratio of the ODA received (in %) in Cabo Verde in 1983 to that in 1987?
Your answer should be very brief. 1.19. What is the ratio of the ODA received (in %) in Guinea-Bissau in 1983 to that in 1987?
Make the answer very short. 0.58. What is the ratio of the ODA received (in %) in Niger in 1983 to that in 1987?
Offer a terse response. 0.6. What is the ratio of the ODA received (in %) in Cabo Verde in 1984 to that in 1985?
Provide a short and direct response. 0.99. What is the ratio of the ODA received (in %) of Guinea-Bissau in 1984 to that in 1985?
Your answer should be compact. 1.11. What is the ratio of the ODA received (in %) in Malta in 1984 to that in 1985?
Provide a short and direct response. 0.62. What is the ratio of the ODA received (in %) in Niger in 1984 to that in 1985?
Make the answer very short. 0.53. What is the ratio of the ODA received (in %) of Cabo Verde in 1984 to that in 1986?
Your answer should be compact. 0.86. What is the ratio of the ODA received (in %) in Guinea-Bissau in 1984 to that in 1986?
Keep it short and to the point. 0.73. What is the ratio of the ODA received (in %) of Malta in 1984 to that in 1986?
Your response must be concise. 2.09. What is the ratio of the ODA received (in %) in Niger in 1984 to that in 1986?
Your answer should be compact. 0.7. What is the ratio of the ODA received (in %) of Cabo Verde in 1984 to that in 1987?
Offer a terse response. 1.32. What is the ratio of the ODA received (in %) in Guinea-Bissau in 1984 to that in 1987?
Your response must be concise. 0.59. What is the ratio of the ODA received (in %) of Niger in 1984 to that in 1987?
Offer a very short reply. 0.69. What is the ratio of the ODA received (in %) of Cabo Verde in 1985 to that in 1986?
Keep it short and to the point. 0.87. What is the ratio of the ODA received (in %) of Guinea-Bissau in 1985 to that in 1986?
Your response must be concise. 0.66. What is the ratio of the ODA received (in %) in Malta in 1985 to that in 1986?
Offer a very short reply. 3.36. What is the ratio of the ODA received (in %) of Niger in 1985 to that in 1986?
Offer a very short reply. 1.32. What is the ratio of the ODA received (in %) in Cabo Verde in 1985 to that in 1987?
Your answer should be compact. 1.34. What is the ratio of the ODA received (in %) in Guinea-Bissau in 1985 to that in 1987?
Your response must be concise. 0.53. What is the ratio of the ODA received (in %) in Niger in 1985 to that in 1987?
Offer a terse response. 1.3. What is the ratio of the ODA received (in %) of Cabo Verde in 1986 to that in 1987?
Make the answer very short. 1.54. What is the ratio of the ODA received (in %) of Guinea-Bissau in 1986 to that in 1987?
Make the answer very short. 0.8. What is the ratio of the ODA received (in %) in Niger in 1986 to that in 1987?
Your answer should be compact. 0.99. What is the difference between the highest and the second highest ODA received (in %) in Cabo Verde?
Give a very brief answer. 7.26. What is the difference between the highest and the second highest ODA received (in %) in Guinea-Bissau?
Ensure brevity in your answer.  11.64. What is the difference between the highest and the second highest ODA received (in %) of Malta?
Provide a succinct answer. 0.14. What is the difference between the highest and the second highest ODA received (in %) in Niger?
Keep it short and to the point. 4.95. What is the difference between the highest and the lowest ODA received (in %) in Cabo Verde?
Keep it short and to the point. 20.59. What is the difference between the highest and the lowest ODA received (in %) in Guinea-Bissau?
Your answer should be compact. 31.7. What is the difference between the highest and the lowest ODA received (in %) in Malta?
Ensure brevity in your answer.  3.63. What is the difference between the highest and the lowest ODA received (in %) in Niger?
Make the answer very short. 14.6. 